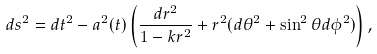Convert formula to latex. <formula><loc_0><loc_0><loc_500><loc_500>d s ^ { 2 } = d t ^ { 2 } - a ^ { 2 } ( t ) \left ( \frac { d r ^ { 2 } } { 1 - k r ^ { 2 } } + r ^ { 2 } ( d \theta ^ { 2 } + \sin ^ { 2 } \theta d \phi ^ { 2 } ) \right ) ,</formula> 